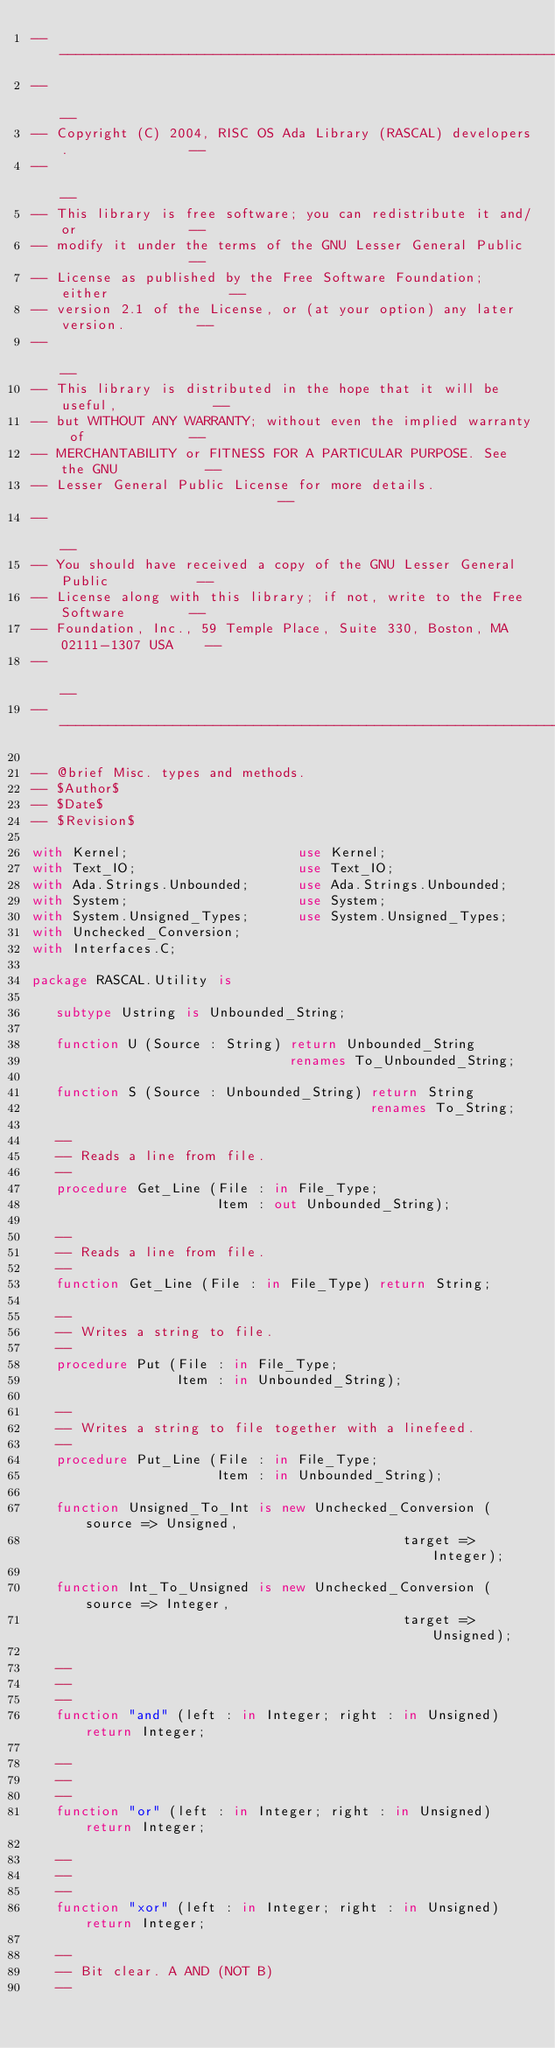Convert code to text. <code><loc_0><loc_0><loc_500><loc_500><_Ada_>--------------------------------------------------------------------------------
--                                                                            --
-- Copyright (C) 2004, RISC OS Ada Library (RASCAL) developers.               --
--                                                                            --
-- This library is free software; you can redistribute it and/or              --
-- modify it under the terms of the GNU Lesser General Public                 --
-- License as published by the Free Software Foundation; either               --
-- version 2.1 of the License, or (at your option) any later version.         --
--                                                                            --
-- This library is distributed in the hope that it will be useful,            --
-- but WITHOUT ANY WARRANTY; without even the implied warranty of             --
-- MERCHANTABILITY or FITNESS FOR A PARTICULAR PURPOSE. See the GNU           --
-- Lesser General Public License for more details.                            --
--                                                                            --
-- You should have received a copy of the GNU Lesser General Public           --
-- License along with this library; if not, write to the Free Software        --
-- Foundation, Inc., 59 Temple Place, Suite 330, Boston, MA 02111-1307 USA    --
--                                                                            --
--------------------------------------------------------------------------------

-- @brief Misc. types and methods.
-- $Author$
-- $Date$
-- $Revision$

with Kernel;                     use Kernel;
with Text_IO;                    use Text_IO;
with Ada.Strings.Unbounded;      use Ada.Strings.Unbounded;
with System;                     use System;
with System.Unsigned_Types;      use System.Unsigned_Types;
with Unchecked_Conversion;
with Interfaces.C;

package RASCAL.Utility is

   subtype Ustring is Unbounded_String;

   function U (Source : String) return Unbounded_String
                                renames To_Unbounded_String;

   function S (Source : Unbounded_String) return String
                                          renames To_String;

   --
   -- Reads a line from file.
   --
   procedure Get_Line (File : in File_Type;
                       Item : out Unbounded_String);

   --
   -- Reads a line from file.
   --
   function Get_Line (File : in File_Type) return String;

   --
   -- Writes a string to file.
   --
   procedure Put (File : in File_Type;
                  Item : in Unbounded_String);

   --
   -- Writes a string to file together with a linefeed.
   --
   procedure Put_Line (File : in File_Type;
                       Item : in Unbounded_String);

   function Unsigned_To_Int is new Unchecked_Conversion (source => Unsigned,
                                              target => Integer);

   function Int_To_Unsigned is new Unchecked_Conversion (source => Integer,
                                              target => Unsigned);

   --
   --
   --
   function "and" (left : in Integer; right : in Unsigned) return Integer;

   --
   --
   --
   function "or" (left : in Integer; right : in Unsigned) return Integer;

   --
   --
   --
   function "xor" (left : in Integer; right : in Unsigned) return Integer;

   --
   -- Bit clear. A AND (NOT B)
   --</code> 